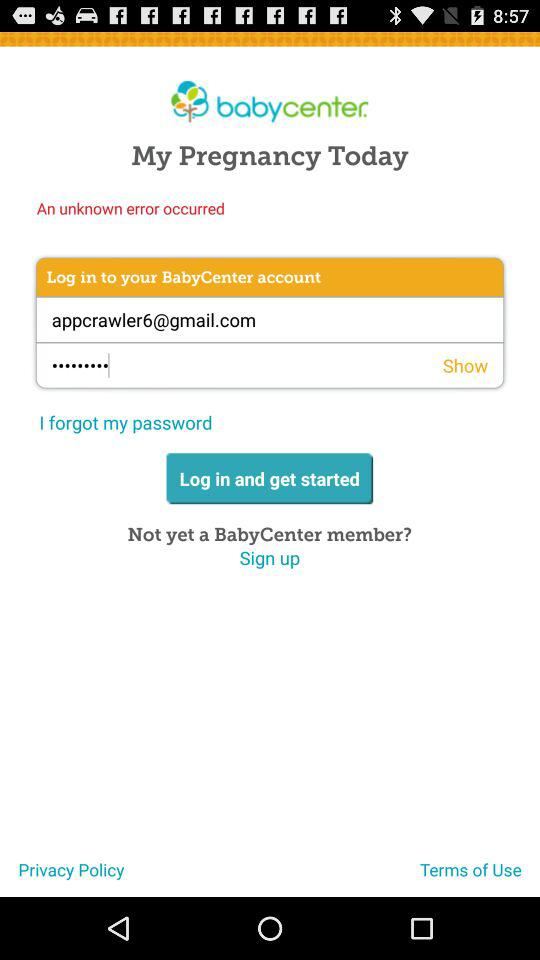What is the email address? The email address is appcrawler6@gmail.com. 